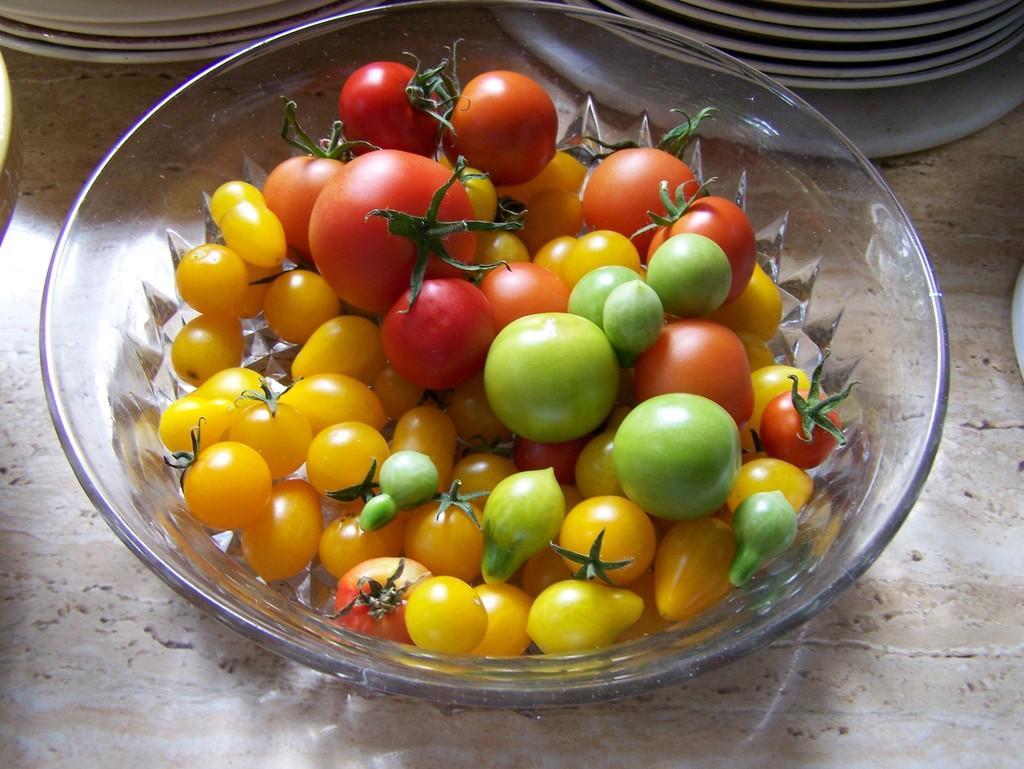Describe this image in one or two sentences. In this picture there are tomatoes in the bowl. At the back there are plates. At the bottom it might be table. 